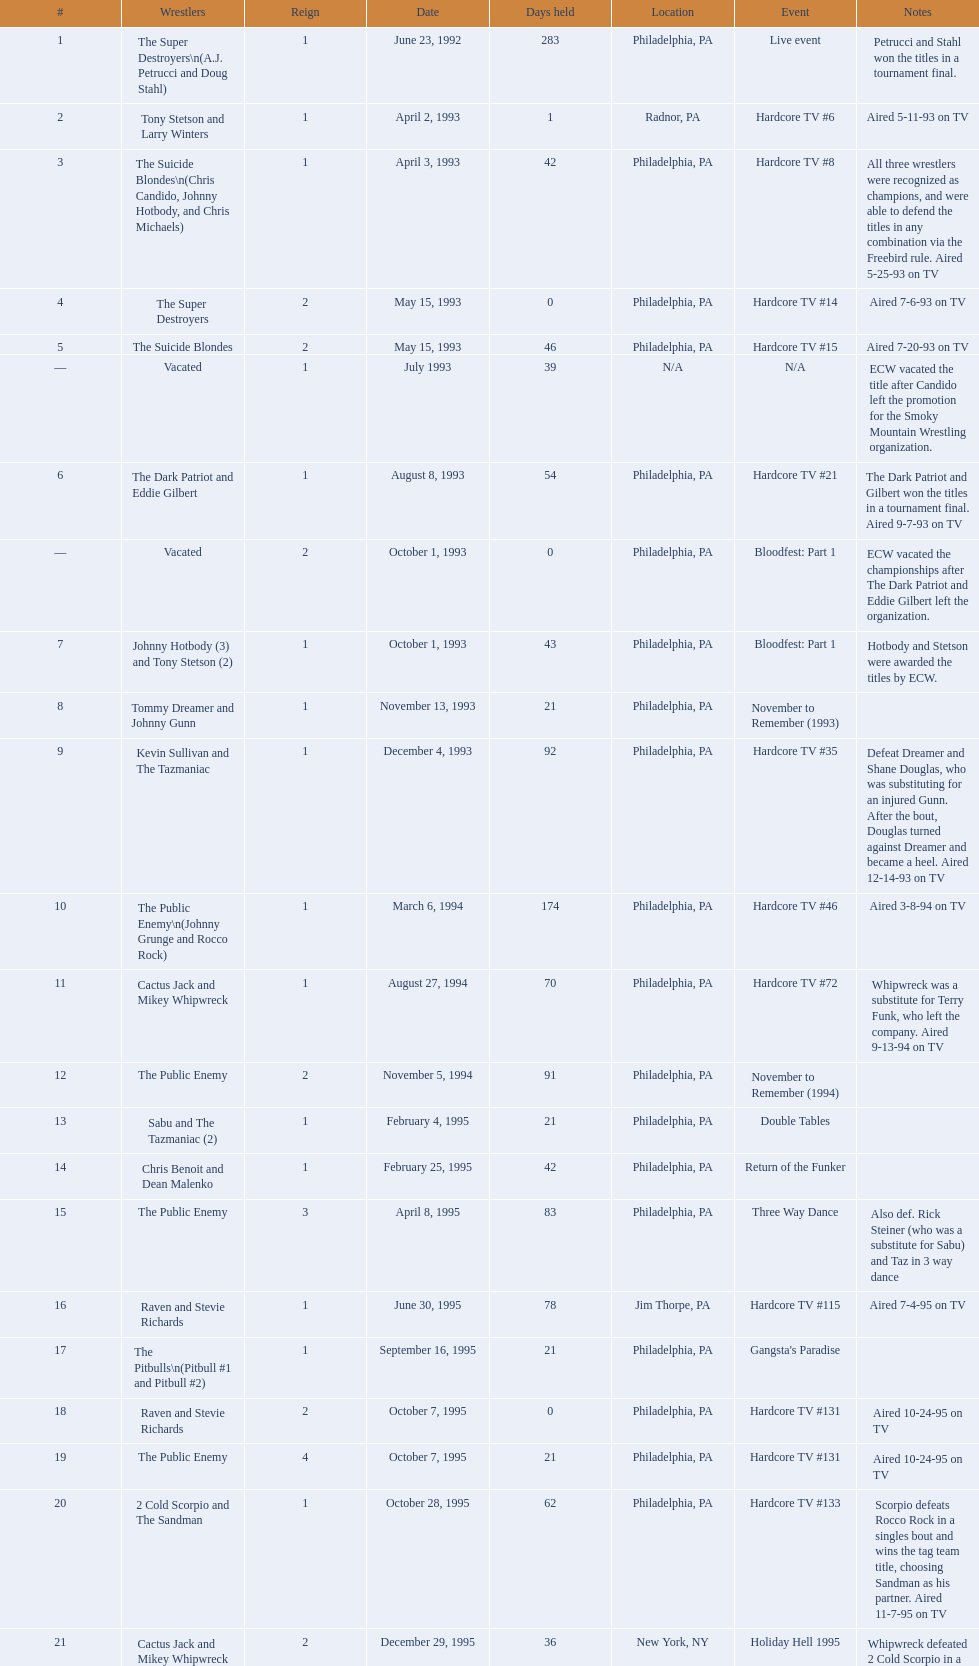Between june 23, 1992 and december 3, 2000, how many instances did the suicide blondes possess the championship? 2. 